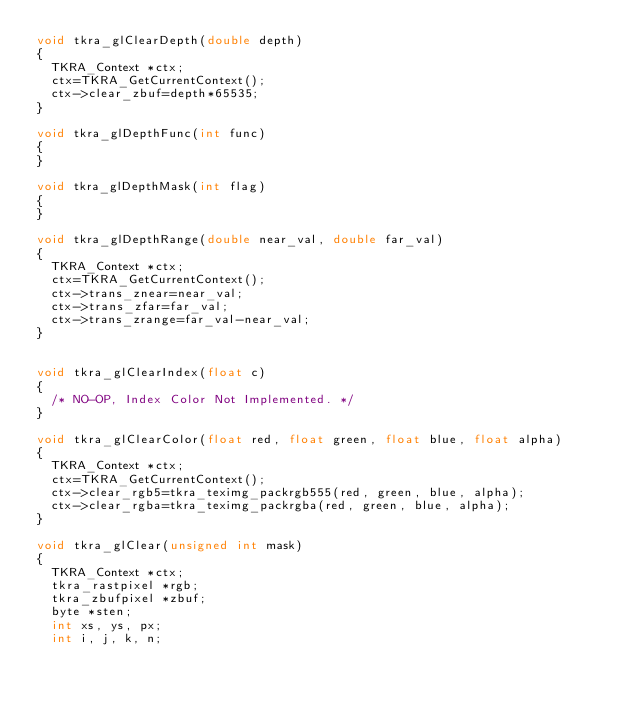<code> <loc_0><loc_0><loc_500><loc_500><_C_>void tkra_glClearDepth(double depth)
{
	TKRA_Context *ctx;
	ctx=TKRA_GetCurrentContext();
	ctx->clear_zbuf=depth*65535;
}

void tkra_glDepthFunc(int func)
{
}

void tkra_glDepthMask(int flag)
{
}

void tkra_glDepthRange(double near_val, double far_val)
{
	TKRA_Context *ctx;
	ctx=TKRA_GetCurrentContext();
	ctx->trans_znear=near_val;
	ctx->trans_zfar=far_val;
	ctx->trans_zrange=far_val-near_val;
}


void tkra_glClearIndex(float c)
{
	/* NO-OP, Index Color Not Implemented. */
}

void tkra_glClearColor(float red, float green, float blue, float alpha)
{
	TKRA_Context *ctx;
	ctx=TKRA_GetCurrentContext();
	ctx->clear_rgb5=tkra_teximg_packrgb555(red, green, blue, alpha);
	ctx->clear_rgba=tkra_teximg_packrgba(red, green, blue, alpha);
}

void tkra_glClear(unsigned int mask)
{
	TKRA_Context *ctx;
	tkra_rastpixel *rgb;
	tkra_zbufpixel *zbuf;
	byte *sten;
	int xs, ys, px;
	int i, j, k, n;
	</code> 